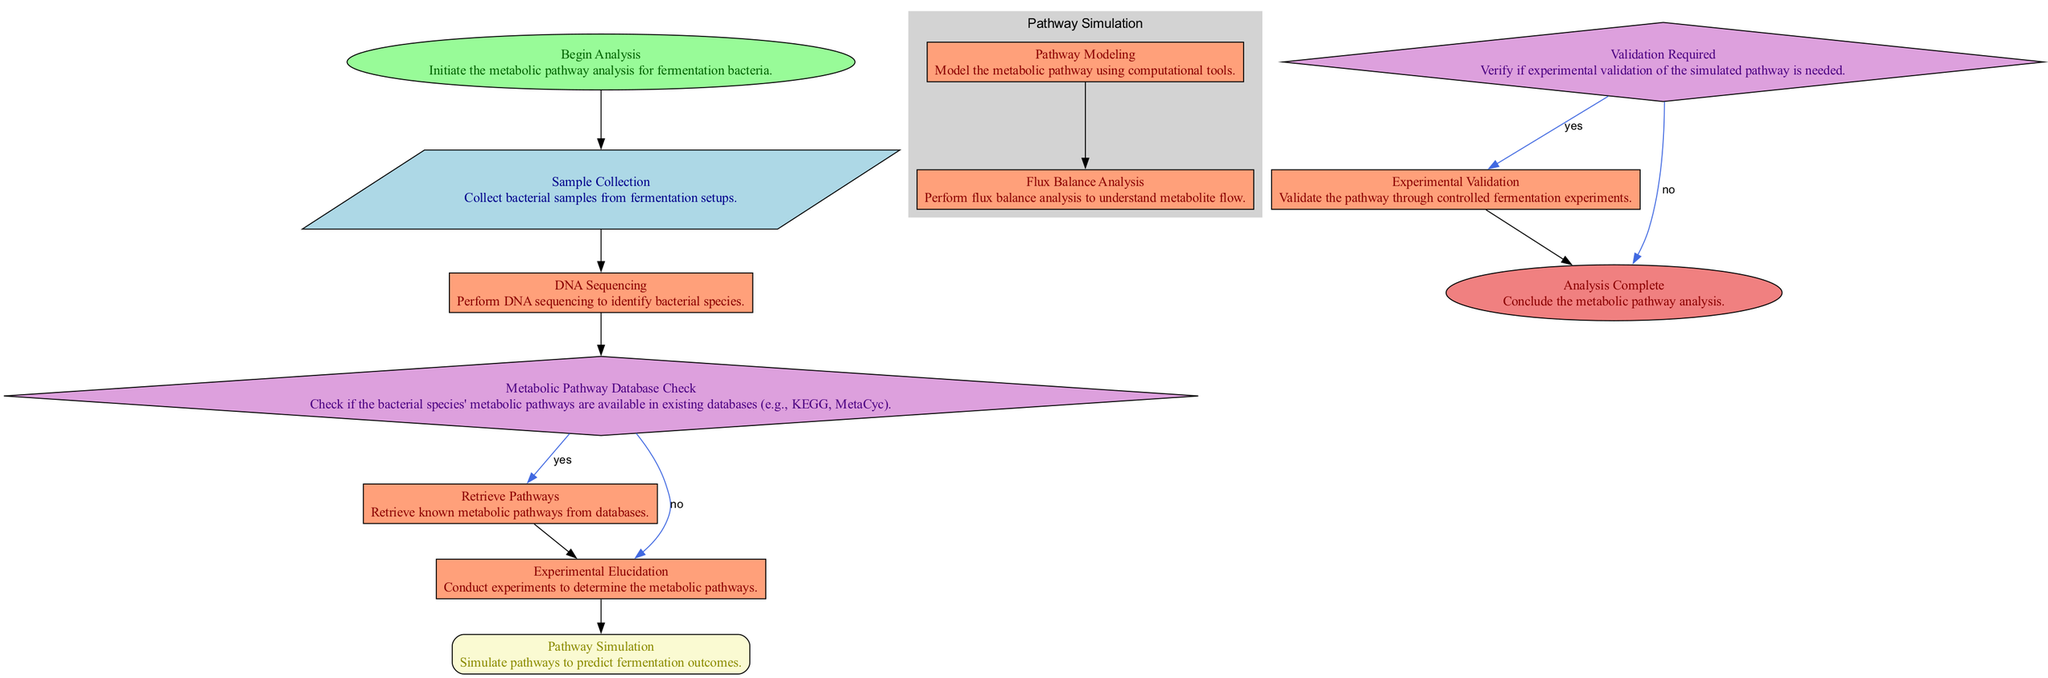What is the first step in the analysis? The diagram indicates that the first step is to "Begin Analysis." This is the initial node before any other processes or decisions begin.
Answer: Begin Analysis How many main processes are there in the diagram? By examining the diagram, we can see there are four main processes: DNA Sequencing, Retrieve Pathways, Experimental Elucidation, and Experimental Validation.
Answer: Four What does the "Metabolic Pathway Database Check" determine? This decision node determines whether the metabolic pathways of the bacterial species can be retrieved from existing databases or if experimental elucidation is necessary.
Answer: Retrieval or experimentation What happens if "Experimental Validation" is required? If "Experimental Validation" is needed, the process moves to the "Experimental Validation" node where validation is conducted through controlled fermentation experiments.
Answer: Experimental Validation What are the two outcomes of the "Validation Required" decision? The two outcomes are either proceeding with "Experimental Validation" if needed or concluding with "Analysis Complete" if not.
Answer: Experimental Validation or Analysis Complete Which subprocesses are involved in "Pathway Simulation"? The subprocesses under "Pathway Simulation" include "Pathway Modeling" and "Flux Balance Analysis." These are both specific processes that aim to predict fermentation outcomes.
Answer: Pathway Modeling and Flux Balance Analysis What is done during "Sample Collection"? In this step, bacterial samples are collected from fermentation setups which serve as the starting point for further analysis.
Answer: Collect bacterial samples How are pathways retrieved if available? If the metabolic pathways are available in the database, they are retrieved through the "Retrieve Pathways" process. This happens after confirming presence in the database.
Answer: Retrieve Pathways What denotes the completion of the analysis? The analysis is deemed complete when the final node "Analysis Complete" is reached, indicating the end of the metabolic pathway analysis.
Answer: Analysis Complete 